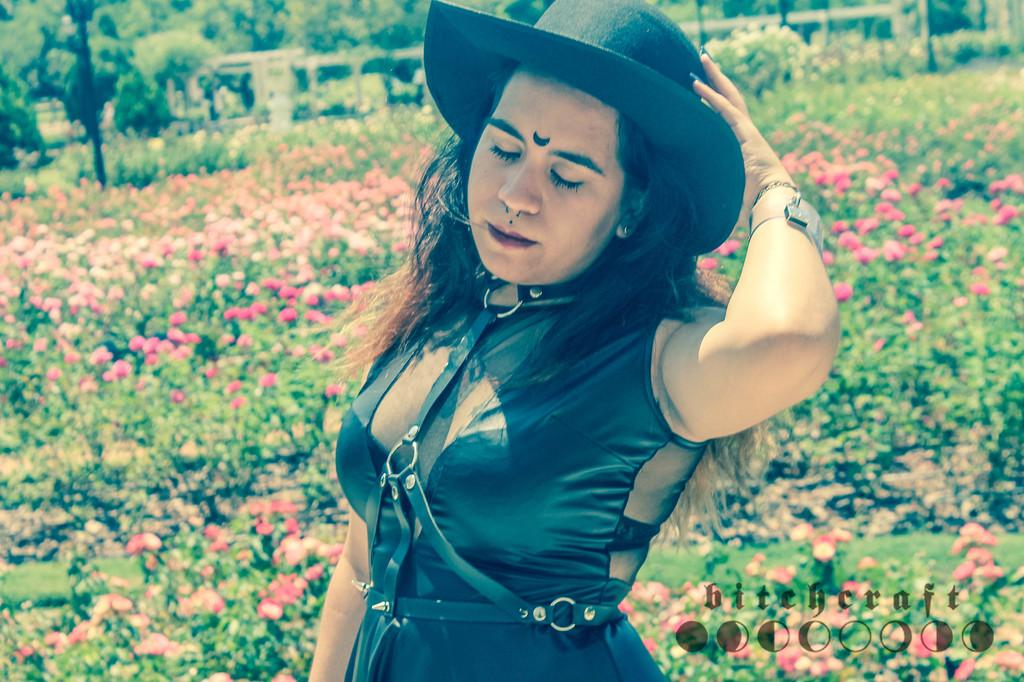Who or what is present in the image? There is a person in the image. What is the person wearing? The person is wearing clothes and a hat. What can be seen in the background of the image? There is a garden in the image. What type of volleyball is being played in the image? There is no volleyball present in the image. What is the weather like in the scene? The provided facts do not mention the weather, so we cannot determine the weather from the image. 